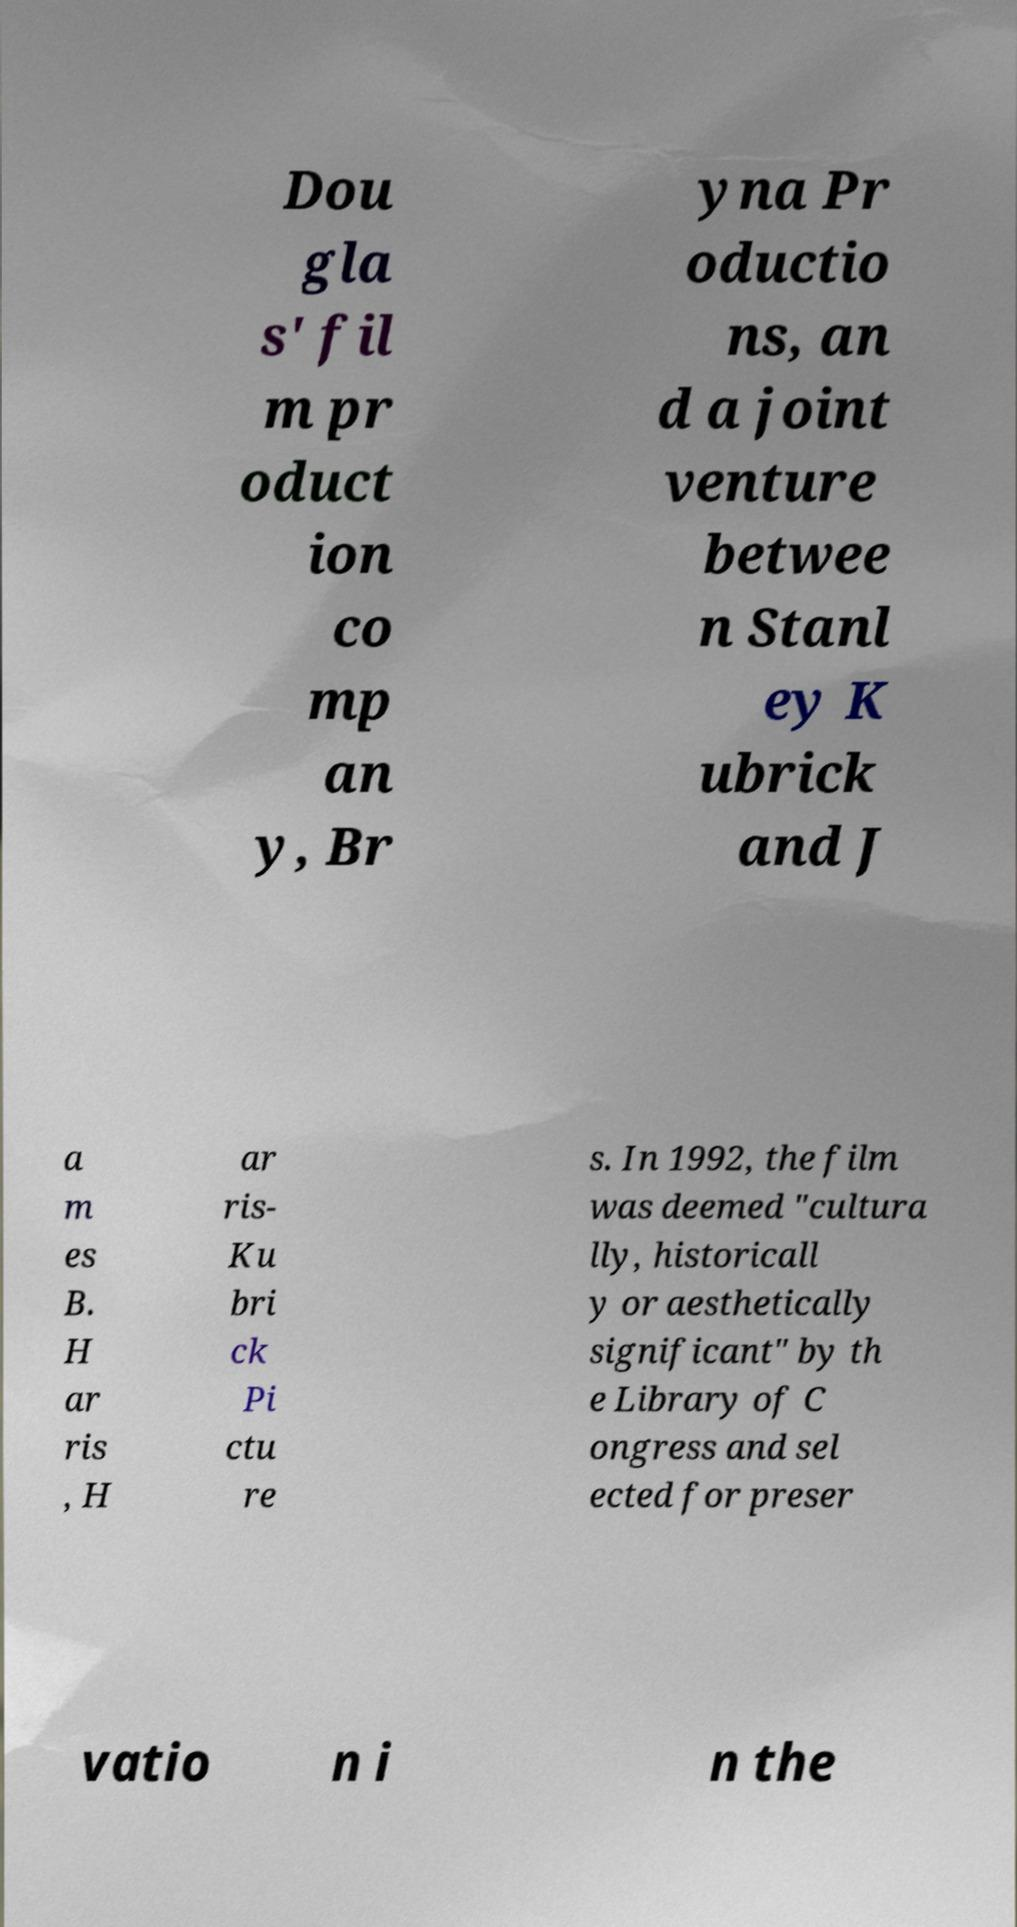What messages or text are displayed in this image? I need them in a readable, typed format. Dou gla s' fil m pr oduct ion co mp an y, Br yna Pr oductio ns, an d a joint venture betwee n Stanl ey K ubrick and J a m es B. H ar ris , H ar ris- Ku bri ck Pi ctu re s. In 1992, the film was deemed "cultura lly, historicall y or aesthetically significant" by th e Library of C ongress and sel ected for preser vatio n i n the 